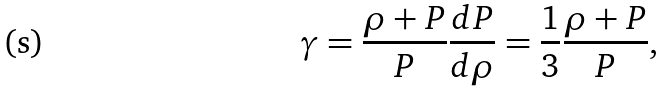<formula> <loc_0><loc_0><loc_500><loc_500>\gamma = \frac { \rho + P } { P } \frac { d P } { d \rho } = \frac { 1 } { 3 } \frac { \rho + P } { P } ,</formula> 